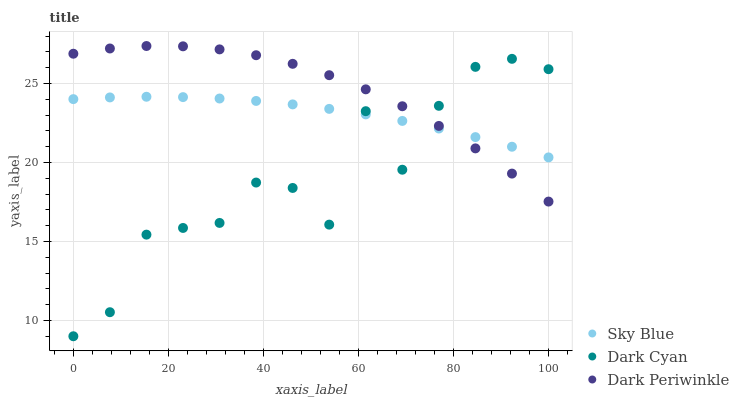Does Dark Cyan have the minimum area under the curve?
Answer yes or no. Yes. Does Dark Periwinkle have the maximum area under the curve?
Answer yes or no. Yes. Does Sky Blue have the minimum area under the curve?
Answer yes or no. No. Does Sky Blue have the maximum area under the curve?
Answer yes or no. No. Is Sky Blue the smoothest?
Answer yes or no. Yes. Is Dark Cyan the roughest?
Answer yes or no. Yes. Is Dark Periwinkle the smoothest?
Answer yes or no. No. Is Dark Periwinkle the roughest?
Answer yes or no. No. Does Dark Cyan have the lowest value?
Answer yes or no. Yes. Does Dark Periwinkle have the lowest value?
Answer yes or no. No. Does Dark Periwinkle have the highest value?
Answer yes or no. Yes. Does Sky Blue have the highest value?
Answer yes or no. No. Does Sky Blue intersect Dark Periwinkle?
Answer yes or no. Yes. Is Sky Blue less than Dark Periwinkle?
Answer yes or no. No. Is Sky Blue greater than Dark Periwinkle?
Answer yes or no. No. 